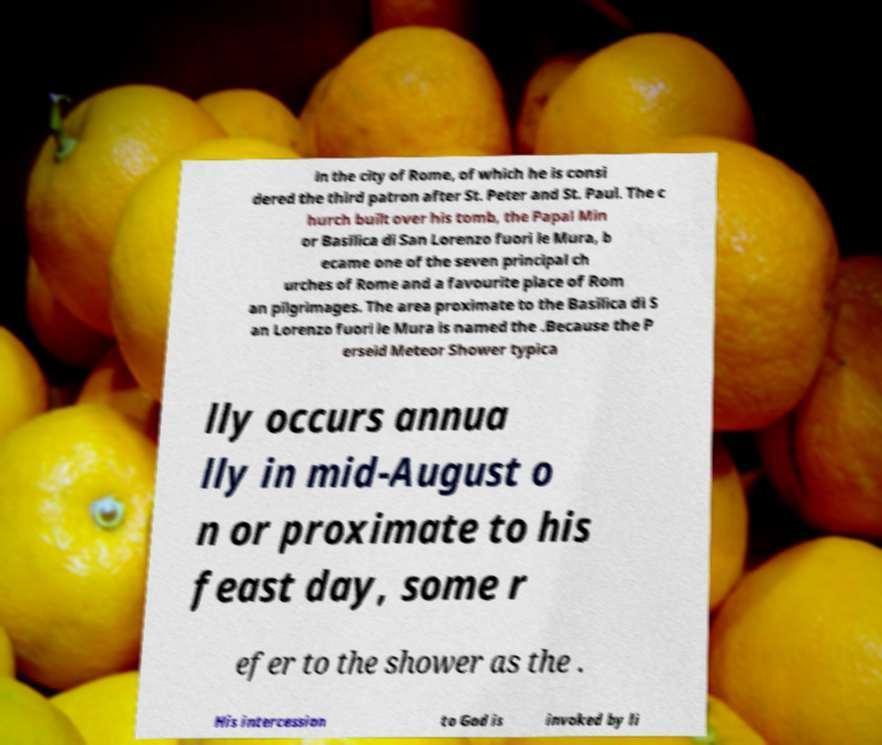Can you read and provide the text displayed in the image?This photo seems to have some interesting text. Can you extract and type it out for me? in the city of Rome, of which he is consi dered the third patron after St. Peter and St. Paul. The c hurch built over his tomb, the Papal Min or Basilica di San Lorenzo fuori le Mura, b ecame one of the seven principal ch urches of Rome and a favourite place of Rom an pilgrimages. The area proximate to the Basilica di S an Lorenzo fuori le Mura is named the .Because the P erseid Meteor Shower typica lly occurs annua lly in mid-August o n or proximate to his feast day, some r efer to the shower as the . His intercession to God is invoked by li 